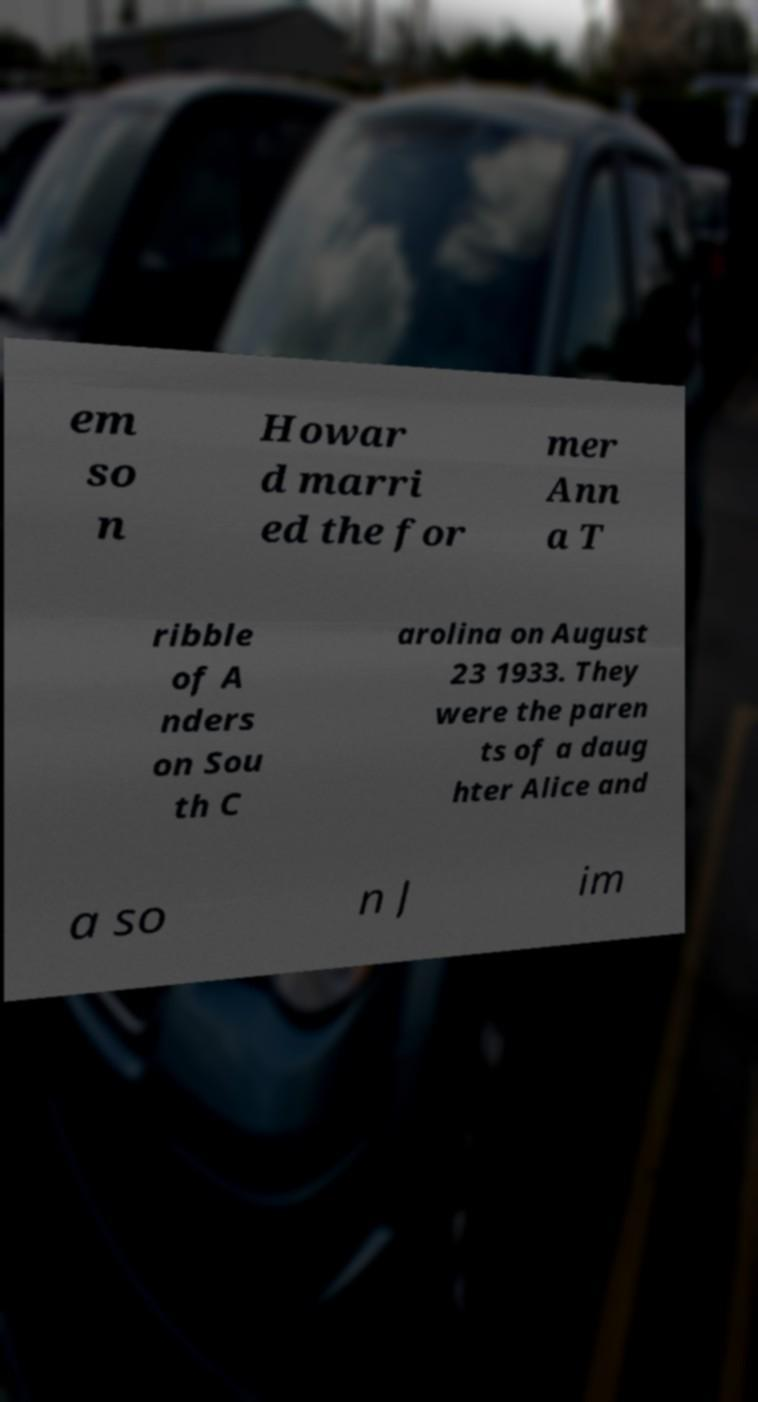There's text embedded in this image that I need extracted. Can you transcribe it verbatim? em so n Howar d marri ed the for mer Ann a T ribble of A nders on Sou th C arolina on August 23 1933. They were the paren ts of a daug hter Alice and a so n J im 